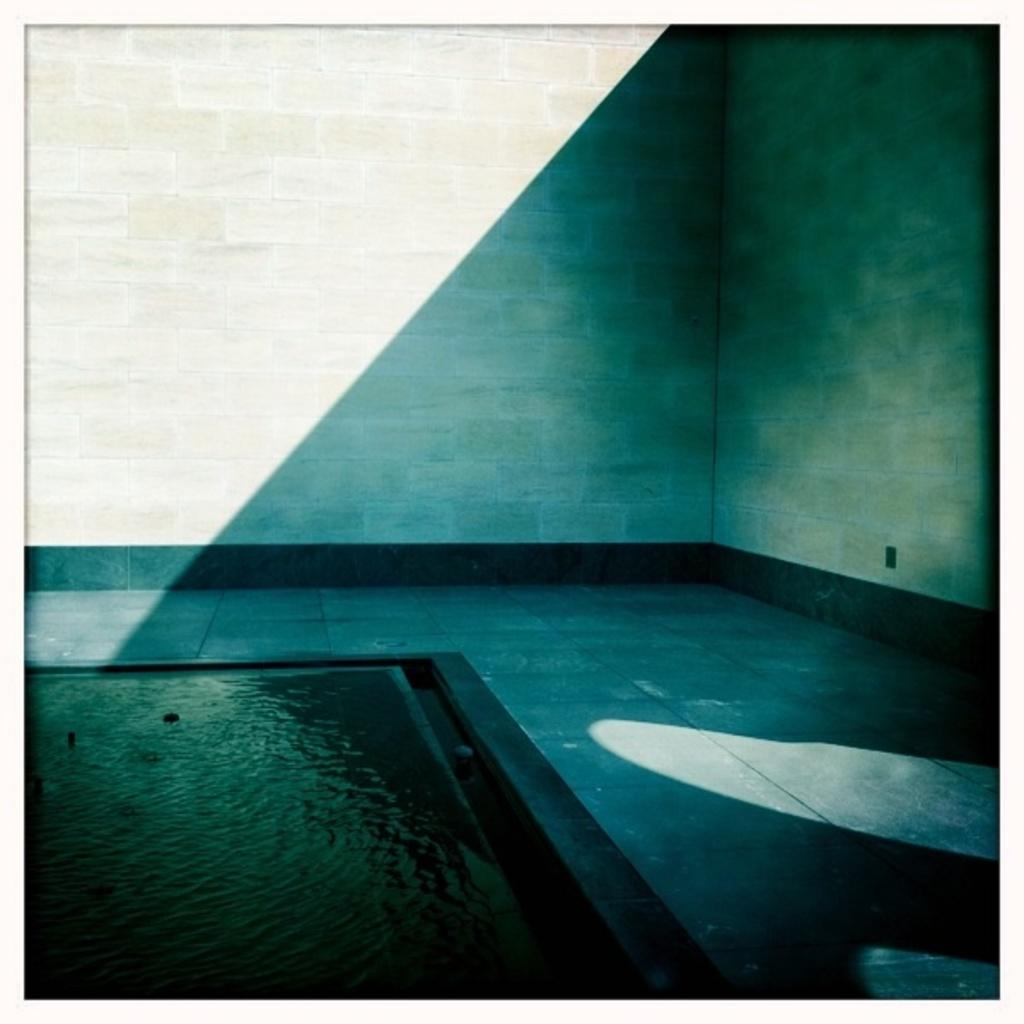What can be seen in the image that is fluid or liquid? There is water visible in the image. What surface is present in the image? There is a floor in the image. What type of structure is visible in the background of the image? There is a wall in the background of the image. How many eggs are present on the floor in the image? There are no eggs visible in the image; it only shows water, a floor, and a wall. Is there any butter melting on the wall in the image? There is no butter present in the image; it only shows water, a floor, and a wall. 